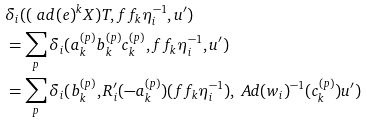Convert formula to latex. <formula><loc_0><loc_0><loc_500><loc_500>& \delta _ { i } ( ( \ a d ( e ) ^ { k } X ) T , f f _ { k } \eta _ { i } ^ { - 1 } , u ^ { \prime } ) \\ & = \sum _ { p } \delta _ { i } ( a _ { k } ^ { ( p ) } b _ { k } ^ { ( p ) } c _ { k } ^ { ( p ) } , f f _ { k } \eta _ { i } ^ { - 1 } , u ^ { \prime } ) \\ & = \sum _ { p } \delta _ { i } ( b _ { k } ^ { ( p ) } , R ^ { \prime } _ { i } ( - a _ { k } ^ { ( p ) } ) ( f f _ { k } \eta _ { i } ^ { - 1 } ) , \ A d ( w _ { i } ) ^ { - 1 } ( c _ { k } ^ { ( p ) } ) u ^ { \prime } )</formula> 